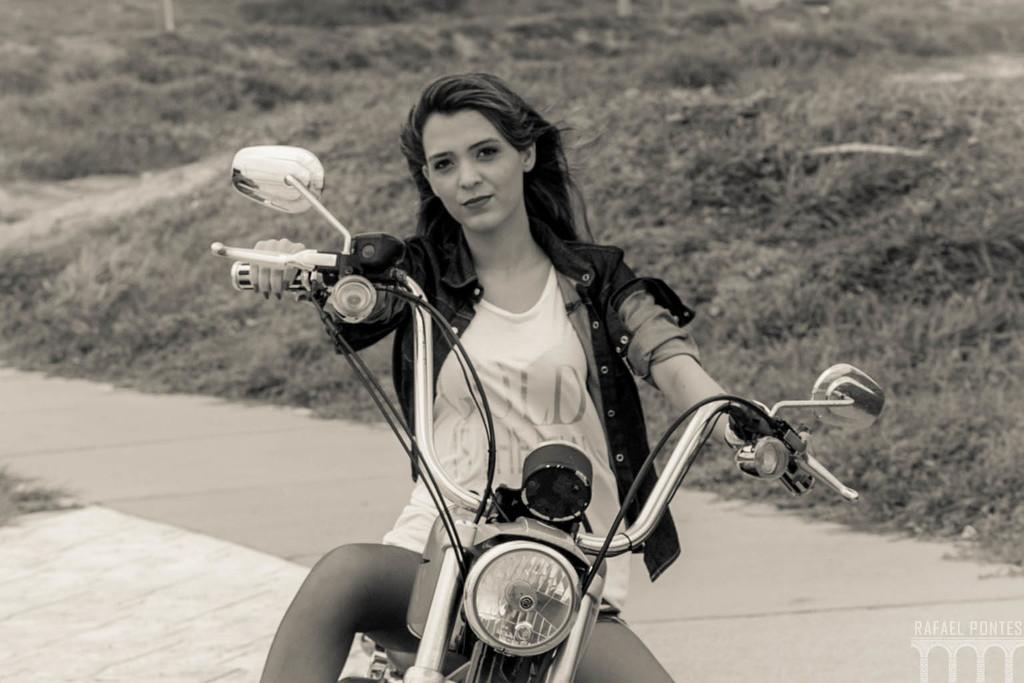Who is the main subject in the image? There is a woman in the image. What is the woman doing in the image? The woman is sitting on a bike. What can be seen in the background of the image? There are plants visible in the background. What type of path is visible in the image? There is a road in the image. Can you tell me how many worms are crawling on the earth in the image? There is no earth or worms present in the image; it features a woman sitting on a bike with plants in the background and a road. 